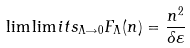Convert formula to latex. <formula><loc_0><loc_0><loc_500><loc_500>\lim \lim i t s _ { \Lambda \rightarrow 0 } F _ { \Lambda } ( n ) = \frac { n ^ { 2 } } { \delta \varepsilon }</formula> 